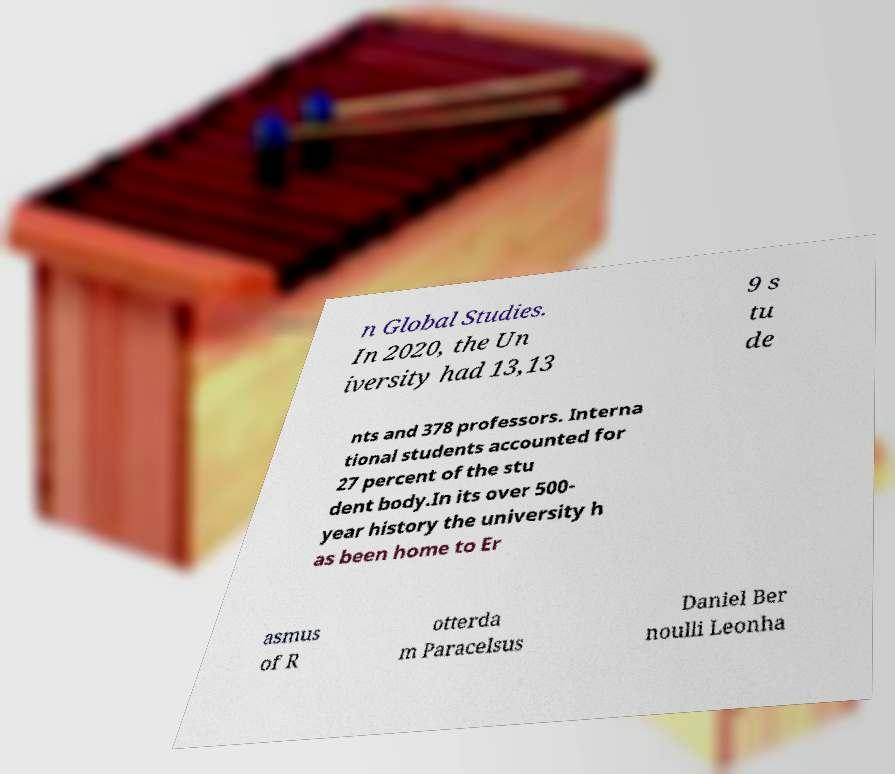There's text embedded in this image that I need extracted. Can you transcribe it verbatim? n Global Studies. In 2020, the Un iversity had 13,13 9 s tu de nts and 378 professors. Interna tional students accounted for 27 percent of the stu dent body.In its over 500- year history the university h as been home to Er asmus of R otterda m Paracelsus Daniel Ber noulli Leonha 